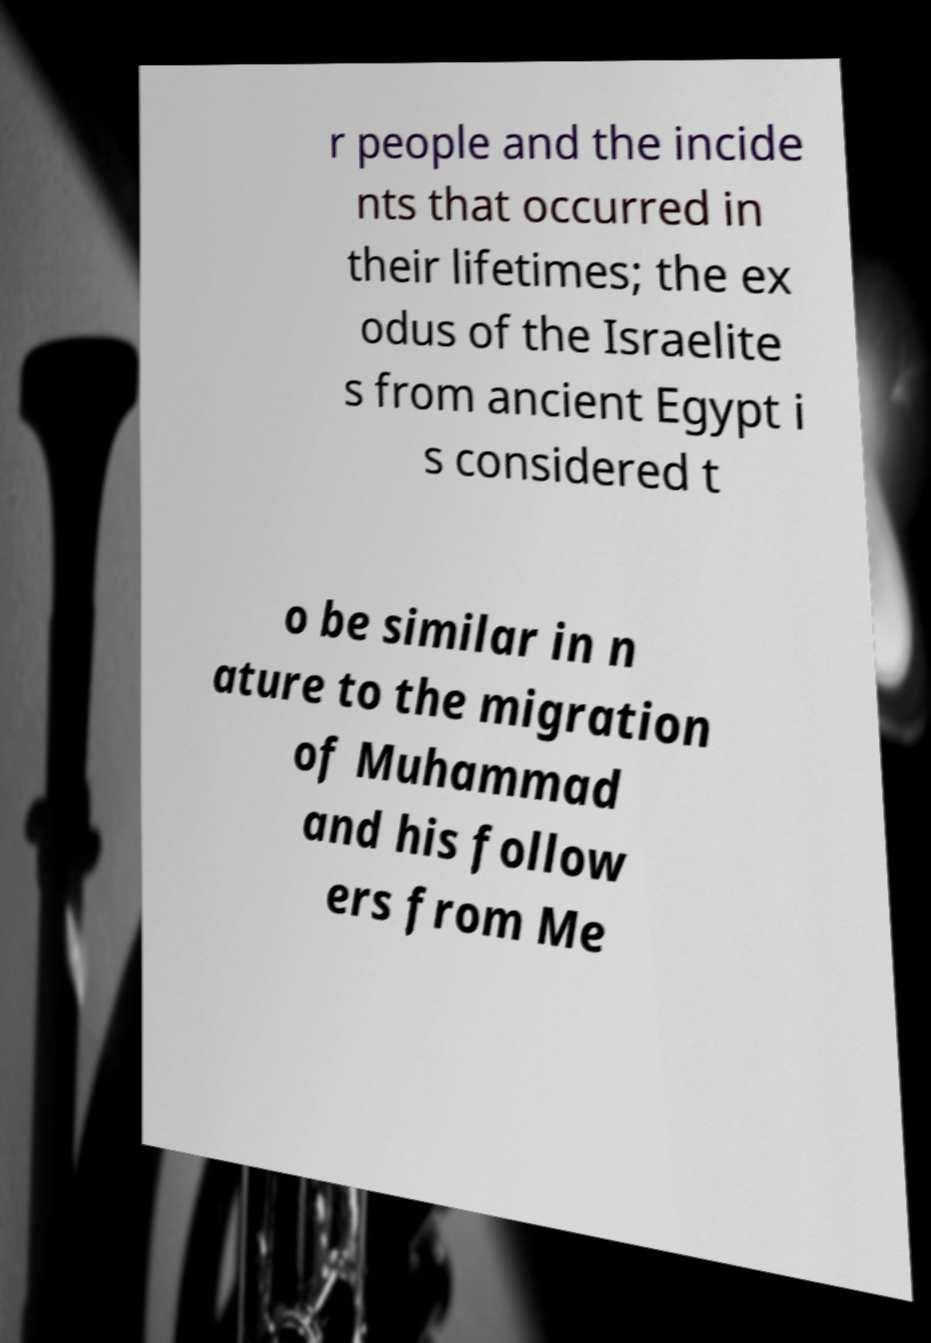Could you extract and type out the text from this image? r people and the incide nts that occurred in their lifetimes; the ex odus of the Israelite s from ancient Egypt i s considered t o be similar in n ature to the migration of Muhammad and his follow ers from Me 